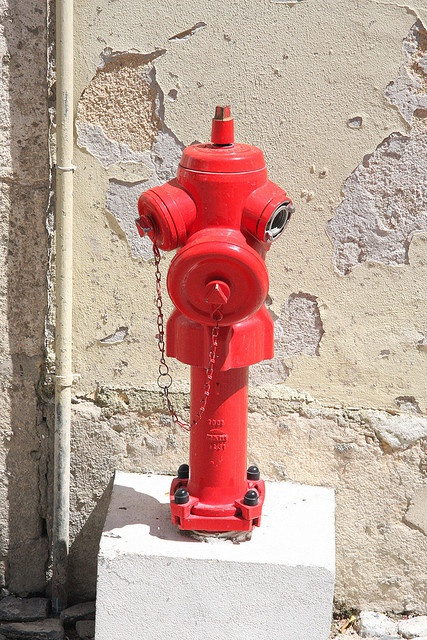Describe the objects in this image and their specific colors. I can see a fire hydrant in lightgray, brown, salmon, red, and lightpink tones in this image. 